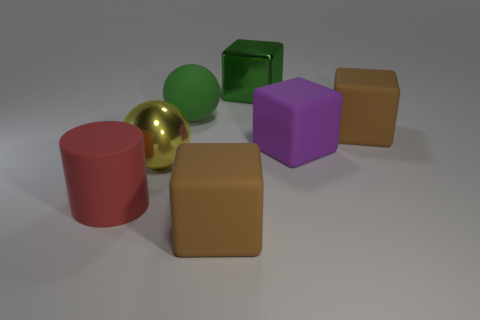What number of purple things are rubber cylinders or rubber spheres?
Your answer should be compact. 0. Does the thing that is in front of the rubber cylinder have the same shape as the large green metallic thing?
Offer a terse response. Yes. Are there more big brown matte blocks that are behind the big purple thing than yellow rubber blocks?
Give a very brief answer. Yes. How many metallic blocks have the same size as the purple matte block?
Give a very brief answer. 1. What size is the rubber sphere that is the same color as the shiny cube?
Ensure brevity in your answer.  Large. What number of things are big rubber spheres or balls that are in front of the purple rubber thing?
Offer a terse response. 2. The object that is in front of the yellow metallic ball and on the left side of the big rubber ball is what color?
Make the answer very short. Red. There is a ball left of the green sphere; what is its color?
Give a very brief answer. Yellow. Are there any large shiny cubes of the same color as the matte sphere?
Your answer should be very brief. Yes. What is the color of the metallic sphere that is the same size as the red object?
Make the answer very short. Yellow. 